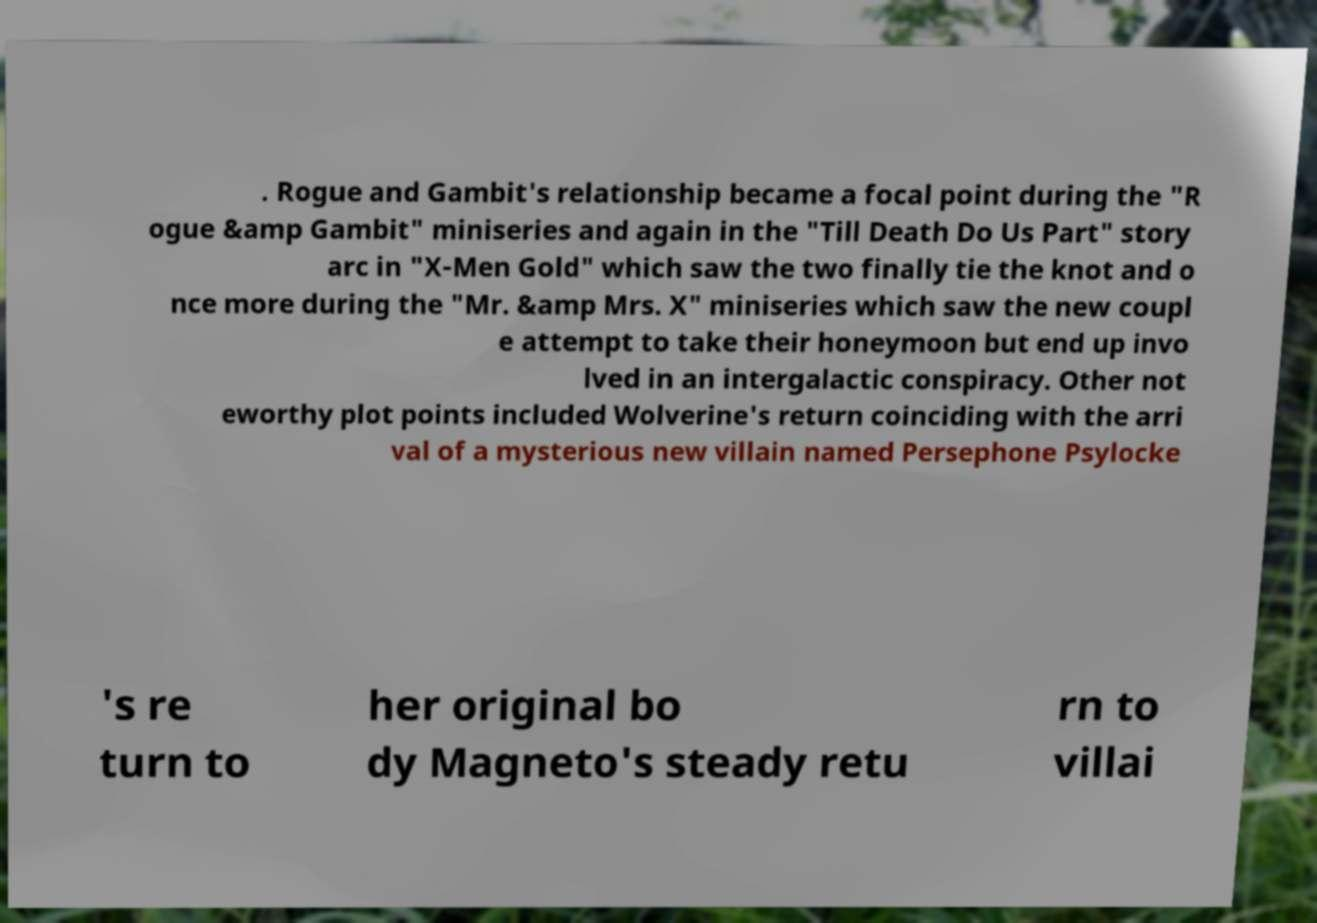Please read and relay the text visible in this image. What does it say? . Rogue and Gambit's relationship became a focal point during the "R ogue &amp Gambit" miniseries and again in the "Till Death Do Us Part" story arc in "X-Men Gold" which saw the two finally tie the knot and o nce more during the "Mr. &amp Mrs. X" miniseries which saw the new coupl e attempt to take their honeymoon but end up invo lved in an intergalactic conspiracy. Other not eworthy plot points included Wolverine's return coinciding with the arri val of a mysterious new villain named Persephone Psylocke 's re turn to her original bo dy Magneto's steady retu rn to villai 